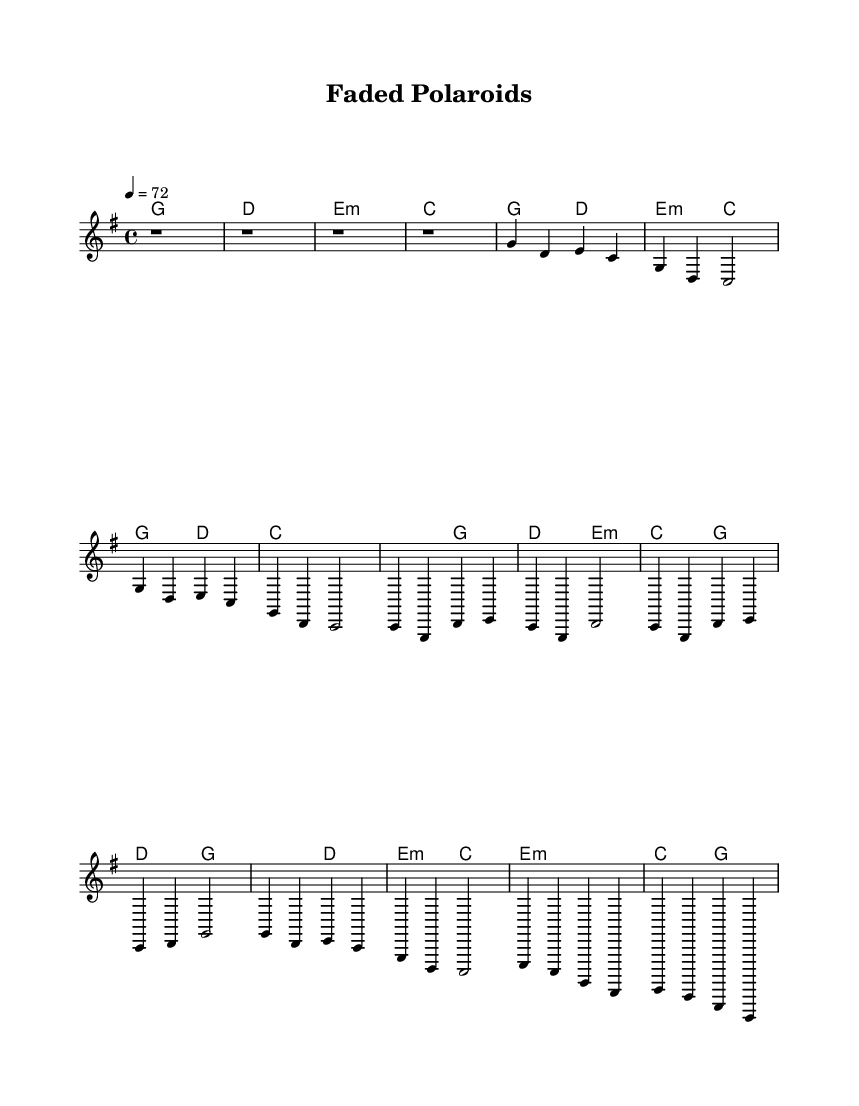What is the key signature of this music? The key signature is G major, which has one sharp (F#). The indication is present at the beginning of the sheet music under the clef symbol.
Answer: G major What is the time signature of this music? The time signature is 4/4, which means there are four beats in each measure and the quarter note gets one beat. This is clearly labeled after the clef symbol at the start of the piece.
Answer: 4/4 What is the tempo marking for this piece? The tempo marking is a quarter note equals 72, indicating the speed at which the music should be played. It appears right after the key signature and time signature at the beginning.
Answer: 72 How many measures are in the chorus section of the song? The chorus section consists of 4 measures. This can be determined by counting the filled-in measures from the chorus melody and harmonies indicated in the score.
Answer: 4 What chord is played during the bridge section? The chord played during the bridge section is E minor. This is seen in the harmonies section at the specified part labeled “Bridge.”
Answer: E minor What type of song is "Faded Polaroids"? "Faded Polaroids" is categorized as a country rock ballad. This is inferred from the title and the lyrical content that deals with themes of lost love and nostalgia, typical of country rock music.
Answer: Country rock ballad What is the last harmony chord shown in the piece? The last harmony chord shown is G major. This can be determined by looking at the last measure of the harmonies section, where the chord is played.
Answer: G major 